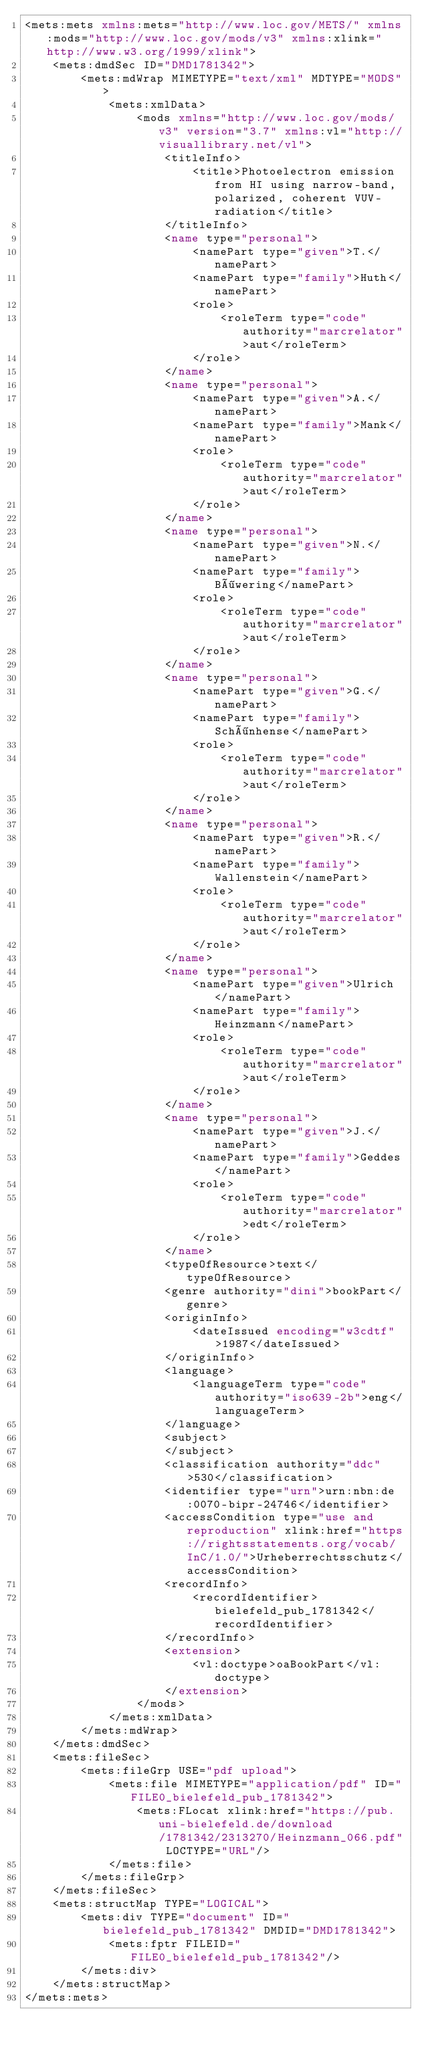<code> <loc_0><loc_0><loc_500><loc_500><_XML_><mets:mets xmlns:mets="http://www.loc.gov/METS/" xmlns:mods="http://www.loc.gov/mods/v3" xmlns:xlink="http://www.w3.org/1999/xlink">
    <mets:dmdSec ID="DMD1781342">
        <mets:mdWrap MIMETYPE="text/xml" MDTYPE="MODS">
            <mets:xmlData>
                <mods xmlns="http://www.loc.gov/mods/v3" version="3.7" xmlns:vl="http://visuallibrary.net/vl">
                    <titleInfo>
                        <title>Photoelectron emission from HI using narrow-band, polarized, coherent VUV-radiation</title>
                    </titleInfo>
                    <name type="personal">
                        <namePart type="given">T.</namePart>
                        <namePart type="family">Huth</namePart>
                        <role>
                            <roleTerm type="code" authority="marcrelator">aut</roleTerm>
                        </role>
                    </name>
                    <name type="personal">
                        <namePart type="given">A.</namePart>
                        <namePart type="family">Mank</namePart>
                        <role>
                            <roleTerm type="code" authority="marcrelator">aut</roleTerm>
                        </role>
                    </name>
                    <name type="personal">
                        <namePart type="given">N.</namePart>
                        <namePart type="family">Böwering</namePart>
                        <role>
                            <roleTerm type="code" authority="marcrelator">aut</roleTerm>
                        </role>
                    </name>
                    <name type="personal">
                        <namePart type="given">G.</namePart>
                        <namePart type="family">Schönhense</namePart>
                        <role>
                            <roleTerm type="code" authority="marcrelator">aut</roleTerm>
                        </role>
                    </name>
                    <name type="personal">
                        <namePart type="given">R.</namePart>
                        <namePart type="family">Wallenstein</namePart>
                        <role>
                            <roleTerm type="code" authority="marcrelator">aut</roleTerm>
                        </role>
                    </name>
                    <name type="personal">
                        <namePart type="given">Ulrich</namePart>
                        <namePart type="family">Heinzmann</namePart>
                        <role>
                            <roleTerm type="code" authority="marcrelator">aut</roleTerm>
                        </role>
                    </name>
                    <name type="personal">
                        <namePart type="given">J.</namePart>
                        <namePart type="family">Geddes</namePart>
                        <role>
                            <roleTerm type="code" authority="marcrelator">edt</roleTerm>
                        </role>
                    </name>
                    <typeOfResource>text</typeOfResource>
                    <genre authority="dini">bookPart</genre>
                    <originInfo>
                        <dateIssued encoding="w3cdtf">1987</dateIssued>
                    </originInfo>
                    <language>
                        <languageTerm type="code" authority="iso639-2b">eng</languageTerm>
                    </language>
                    <subject>
                    </subject>
                    <classification authority="ddc">530</classification>
                    <identifier type="urn">urn:nbn:de:0070-bipr-24746</identifier>
                    <accessCondition type="use and reproduction" xlink:href="https://rightsstatements.org/vocab/InC/1.0/">Urheberrechtsschutz</accessCondition>
                    <recordInfo>
                        <recordIdentifier>bielefeld_pub_1781342</recordIdentifier>
                    </recordInfo>
                    <extension>
                        <vl:doctype>oaBookPart</vl:doctype>
                    </extension>
                </mods>
            </mets:xmlData>
        </mets:mdWrap>
    </mets:dmdSec>
    <mets:fileSec>
        <mets:fileGrp USE="pdf upload">
            <mets:file MIMETYPE="application/pdf" ID="FILE0_bielefeld_pub_1781342">
                <mets:FLocat xlink:href="https://pub.uni-bielefeld.de/download/1781342/2313270/Heinzmann_066.pdf" LOCTYPE="URL"/>
            </mets:file>
        </mets:fileGrp>
    </mets:fileSec>
    <mets:structMap TYPE="LOGICAL">
        <mets:div TYPE="document" ID="bielefeld_pub_1781342" DMDID="DMD1781342">
            <mets:fptr FILEID="FILE0_bielefeld_pub_1781342"/>
        </mets:div>
    </mets:structMap>
</mets:mets>
</code> 